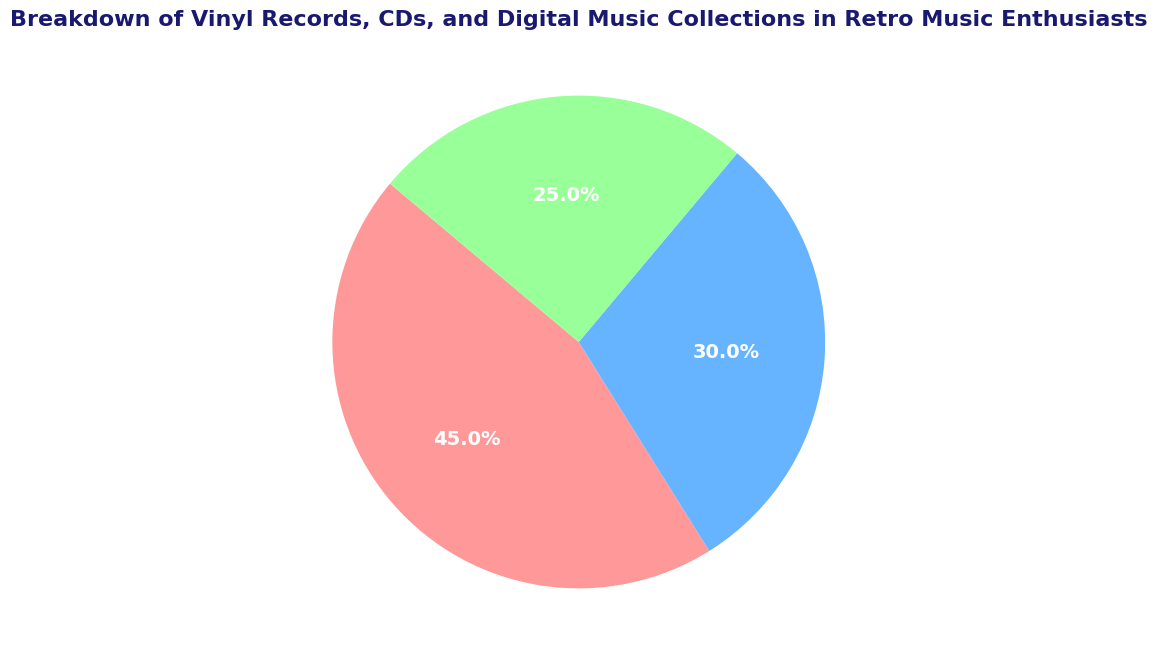What percentage of retro music enthusiasts' collections do vinyl records constitute? To find the percentage of vinyl records, look at the figure's section labeled "Vinyl Records" and check the corresponding percentage.
Answer: 45% Which type of music collection is the least prevalent among retro music enthusiasts? Compare the percentages for Vinyl Records, CDs, and Digital Music. The smallest percentage represents the least prevalent collection. Digital Music has the smallest percentage at 25%.
Answer: Digital Music How much greater is the percentage of CDs compared to Digital Music in enthusiasts' collections? Subtract the percentage of Digital Music from the percentage of CDs: 30% - 25% = 5%.
Answer: 5% What is the sum of the percentages for both Vinyl Records and CDs? Add the percentage of Vinyl Records (45%) to the percentage of CDs (30%): 45% + 30% = 75%.
Answer: 75% If the entire collection represents 100%, what percentage does the Digital Music collection account for? The figure shows that Digital Music accounts for 25% of the entire collection.
Answer: 25% Which category has the largest visual section in the pie chart? The section of the pie chart representing Vinyl Records occupies the largest area.
Answer: Vinyl Records By how much does the percentage of vinyl records exceed the percentage of digital music? Subtract the percentage of Digital Music from the percentage of Vinyl Records: 45% - 25% = 20%.
Answer: 20% Among the three categories, which one has a medium-sized section in the pie chart? Compare the sizes visually and by percentage. Vinyl Records is the largest, Digital Music is the smallest, and CDs are in the middle.
Answer: CDs What is the average percentage of the music collections shared among the three categories? Add the percentages for all three categories and then divide by the number of categories: (45% + 30% + 25%) / 3 = 33.33%.
Answer: 33.33% Which section is represented in green in the pie chart? The section representing Digital Music is green in the pie chart.
Answer: Digital Music 